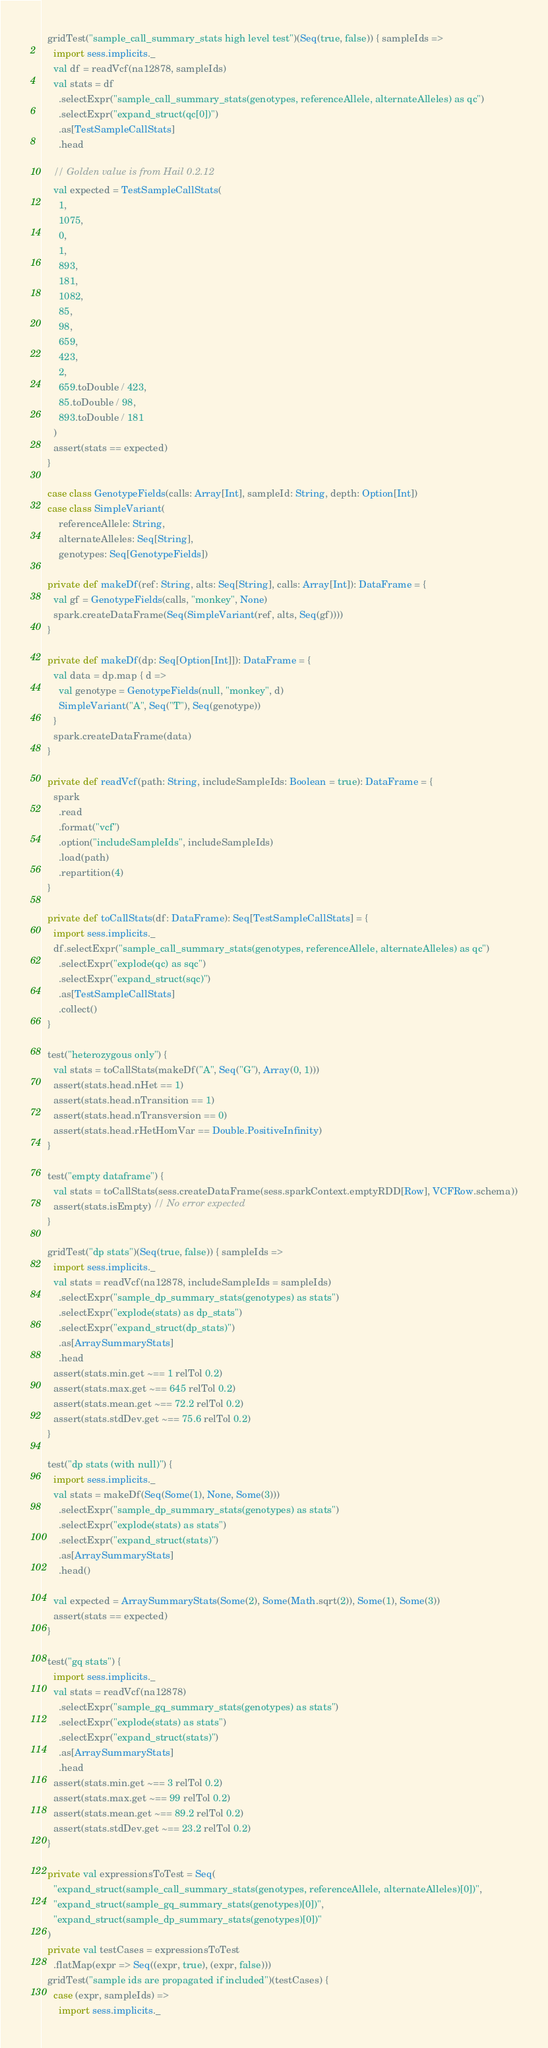<code> <loc_0><loc_0><loc_500><loc_500><_Scala_>
  gridTest("sample_call_summary_stats high level test")(Seq(true, false)) { sampleIds =>
    import sess.implicits._
    val df = readVcf(na12878, sampleIds)
    val stats = df
      .selectExpr("sample_call_summary_stats(genotypes, referenceAllele, alternateAlleles) as qc")
      .selectExpr("expand_struct(qc[0])")
      .as[TestSampleCallStats]
      .head

    // Golden value is from Hail 0.2.12
    val expected = TestSampleCallStats(
      1,
      1075,
      0,
      1,
      893,
      181,
      1082,
      85,
      98,
      659,
      423,
      2,
      659.toDouble / 423,
      85.toDouble / 98,
      893.toDouble / 181
    )
    assert(stats == expected)
  }

  case class GenotypeFields(calls: Array[Int], sampleId: String, depth: Option[Int])
  case class SimpleVariant(
      referenceAllele: String,
      alternateAlleles: Seq[String],
      genotypes: Seq[GenotypeFields])

  private def makeDf(ref: String, alts: Seq[String], calls: Array[Int]): DataFrame = {
    val gf = GenotypeFields(calls, "monkey", None)
    spark.createDataFrame(Seq(SimpleVariant(ref, alts, Seq(gf))))
  }

  private def makeDf(dp: Seq[Option[Int]]): DataFrame = {
    val data = dp.map { d =>
      val genotype = GenotypeFields(null, "monkey", d)
      SimpleVariant("A", Seq("T"), Seq(genotype))
    }
    spark.createDataFrame(data)
  }

  private def readVcf(path: String, includeSampleIds: Boolean = true): DataFrame = {
    spark
      .read
      .format("vcf")
      .option("includeSampleIds", includeSampleIds)
      .load(path)
      .repartition(4)
  }

  private def toCallStats(df: DataFrame): Seq[TestSampleCallStats] = {
    import sess.implicits._
    df.selectExpr("sample_call_summary_stats(genotypes, referenceAllele, alternateAlleles) as qc")
      .selectExpr("explode(qc) as sqc")
      .selectExpr("expand_struct(sqc)")
      .as[TestSampleCallStats]
      .collect()
  }

  test("heterozygous only") {
    val stats = toCallStats(makeDf("A", Seq("G"), Array(0, 1)))
    assert(stats.head.nHet == 1)
    assert(stats.head.nTransition == 1)
    assert(stats.head.nTransversion == 0)
    assert(stats.head.rHetHomVar == Double.PositiveInfinity)
  }

  test("empty dataframe") {
    val stats = toCallStats(sess.createDataFrame(sess.sparkContext.emptyRDD[Row], VCFRow.schema))
    assert(stats.isEmpty) // No error expected
  }

  gridTest("dp stats")(Seq(true, false)) { sampleIds =>
    import sess.implicits._
    val stats = readVcf(na12878, includeSampleIds = sampleIds)
      .selectExpr("sample_dp_summary_stats(genotypes) as stats")
      .selectExpr("explode(stats) as dp_stats")
      .selectExpr("expand_struct(dp_stats)")
      .as[ArraySummaryStats]
      .head
    assert(stats.min.get ~== 1 relTol 0.2)
    assert(stats.max.get ~== 645 relTol 0.2)
    assert(stats.mean.get ~== 72.2 relTol 0.2)
    assert(stats.stdDev.get ~== 75.6 relTol 0.2)
  }

  test("dp stats (with null)") {
    import sess.implicits._
    val stats = makeDf(Seq(Some(1), None, Some(3)))
      .selectExpr("sample_dp_summary_stats(genotypes) as stats")
      .selectExpr("explode(stats) as stats")
      .selectExpr("expand_struct(stats)")
      .as[ArraySummaryStats]
      .head()

    val expected = ArraySummaryStats(Some(2), Some(Math.sqrt(2)), Some(1), Some(3))
    assert(stats == expected)
  }

  test("gq stats") {
    import sess.implicits._
    val stats = readVcf(na12878)
      .selectExpr("sample_gq_summary_stats(genotypes) as stats")
      .selectExpr("explode(stats) as stats")
      .selectExpr("expand_struct(stats)")
      .as[ArraySummaryStats]
      .head
    assert(stats.min.get ~== 3 relTol 0.2)
    assert(stats.max.get ~== 99 relTol 0.2)
    assert(stats.mean.get ~== 89.2 relTol 0.2)
    assert(stats.stdDev.get ~== 23.2 relTol 0.2)
  }

  private val expressionsToTest = Seq(
    "expand_struct(sample_call_summary_stats(genotypes, referenceAllele, alternateAlleles)[0])",
    "expand_struct(sample_gq_summary_stats(genotypes)[0])",
    "expand_struct(sample_dp_summary_stats(genotypes)[0])"
  )
  private val testCases = expressionsToTest
    .flatMap(expr => Seq((expr, true), (expr, false)))
  gridTest("sample ids are propagated if included")(testCases) {
    case (expr, sampleIds) =>
      import sess.implicits._</code> 